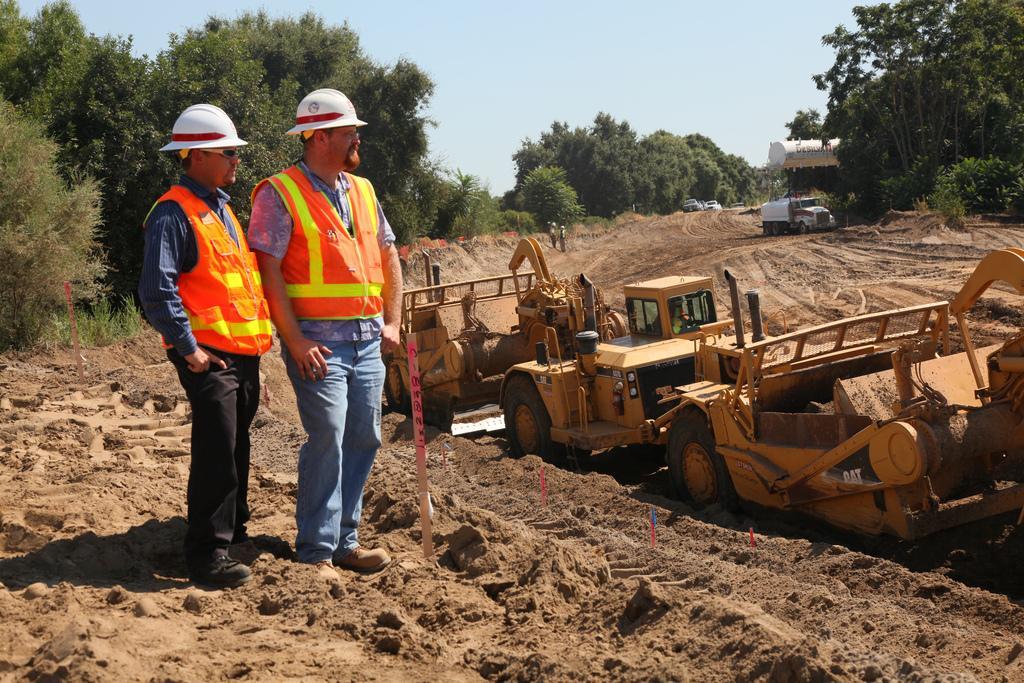Could you give a brief overview of what you see in this image? This image is taken outdoors. At the top of the image there is the sky. In the background there are many trees and plants with leaves, stems and branches. Two cars are parked on the ground. A truck and a vehicle are parked on the ground. On the left side of the image two men are standing on the ground. In the middle of the image there are three cranes parked on the ground and two persons are walking on the ground. 